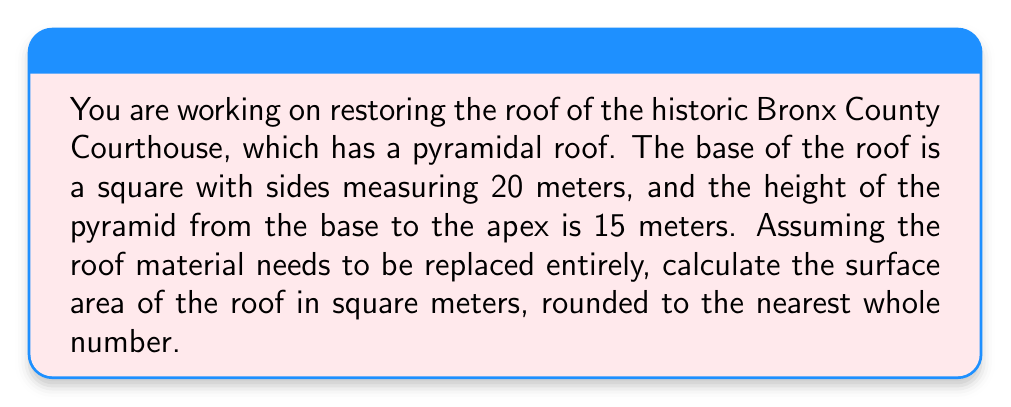Solve this math problem. To solve this problem, we need to follow these steps:

1. Recognize that the roof forms a square-based pyramid.
2. Calculate the slant height of the pyramid using the Pythagorean theorem.
3. Calculate the surface area of the pyramid (excluding the base).

Step 1: The roof is a square-based pyramid with:
- Base side length: $a = 20$ meters
- Height: $h = 15$ meters

Step 2: Calculate the slant height $(l)$ using the Pythagorean theorem:

$$l^2 = (\frac{a}{2})^2 + h^2$$

$$l^2 = 10^2 + 15^2 = 100 + 225 = 325$$

$$l = \sqrt{325} \approx 18.03 \text{ meters}$$

Step 3: Calculate the surface area of the pyramid (excluding the base):

The surface area of a square-based pyramid (excluding the base) is given by:

$$SA = 4 \cdot \frac{1}{2} \cdot a \cdot l$$

Where $a$ is the side length of the base and $l$ is the slant height.

Substituting our values:

$$SA = 4 \cdot \frac{1}{2} \cdot 20 \cdot 18.03$$

$$SA = 2 \cdot 20 \cdot 18.03 = 721.2 \text{ square meters}$$

Rounding to the nearest whole number:

$$SA \approx 721 \text{ square meters}$$

[asy]
import three;

size(200);
currentprojection=perspective(6,3,2);

triple A = (0,0,0), B = (20,0,0), C = (20,20,0), D = (0,20,0), E = (10,10,15);

draw(A--B--C--D--cycle);
draw(A--E--C,dashed);
draw(B--E--D,dashed);

label("A", A, SW);
label("B", B, SE);
label("C", C, NE);
label("D", D, NW);
label("E", E, N);

label("20 m", (A+B)/2, S);
label("15 m", (10,10,0)--(10,10,15), W);
[/asy]
Answer: 721 square meters 